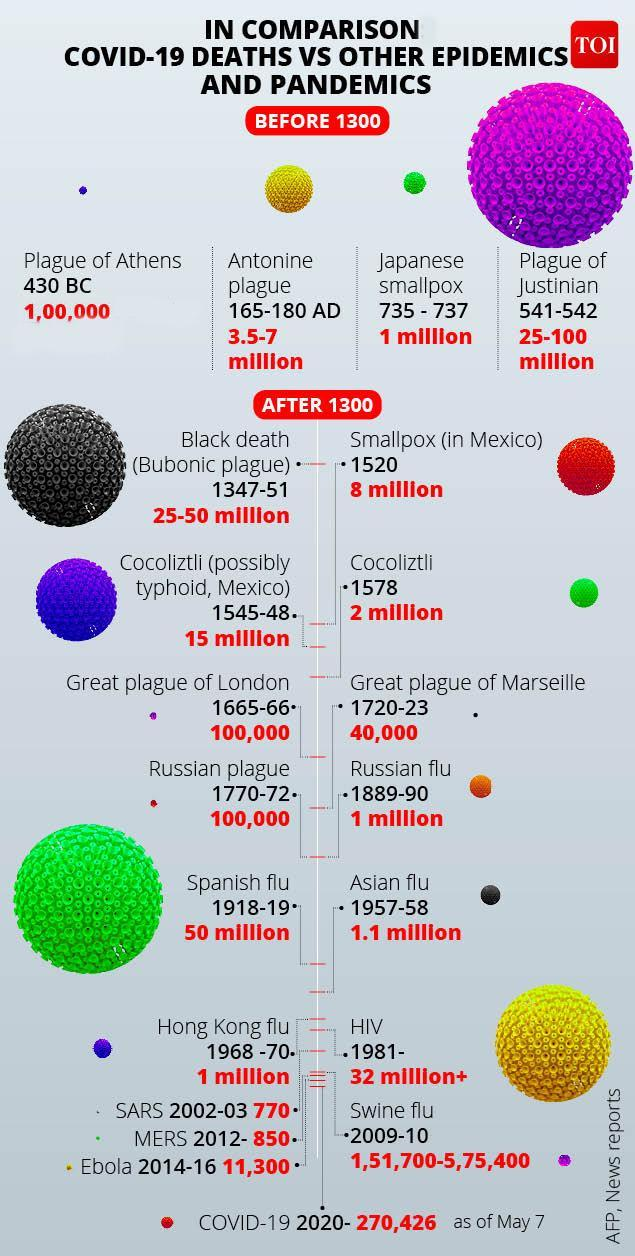What disease outbreak happened in 2014-16 on the African continent?
Answer the question with a short phrase. Ebola What disease outbreak happened in 1918-19? Spanish flu When did the smallpox epidemic started in Mexico? 1520 When did the Russian flu pandemic that killed about 1 million people happened? 1889-90 How many people were killed by Asian flu in 1957-58? 1.1 million What is the number of COVID-19 deaths as of May 7, 2020? 270,426 What is the number of deaths caused by the small pox disease in Mexico in 1520? 8 miilion What disease outbreak happened in 165-180 AD? Antonine plague How many people were killed by Spanish flu in 1918-19? 50 million 